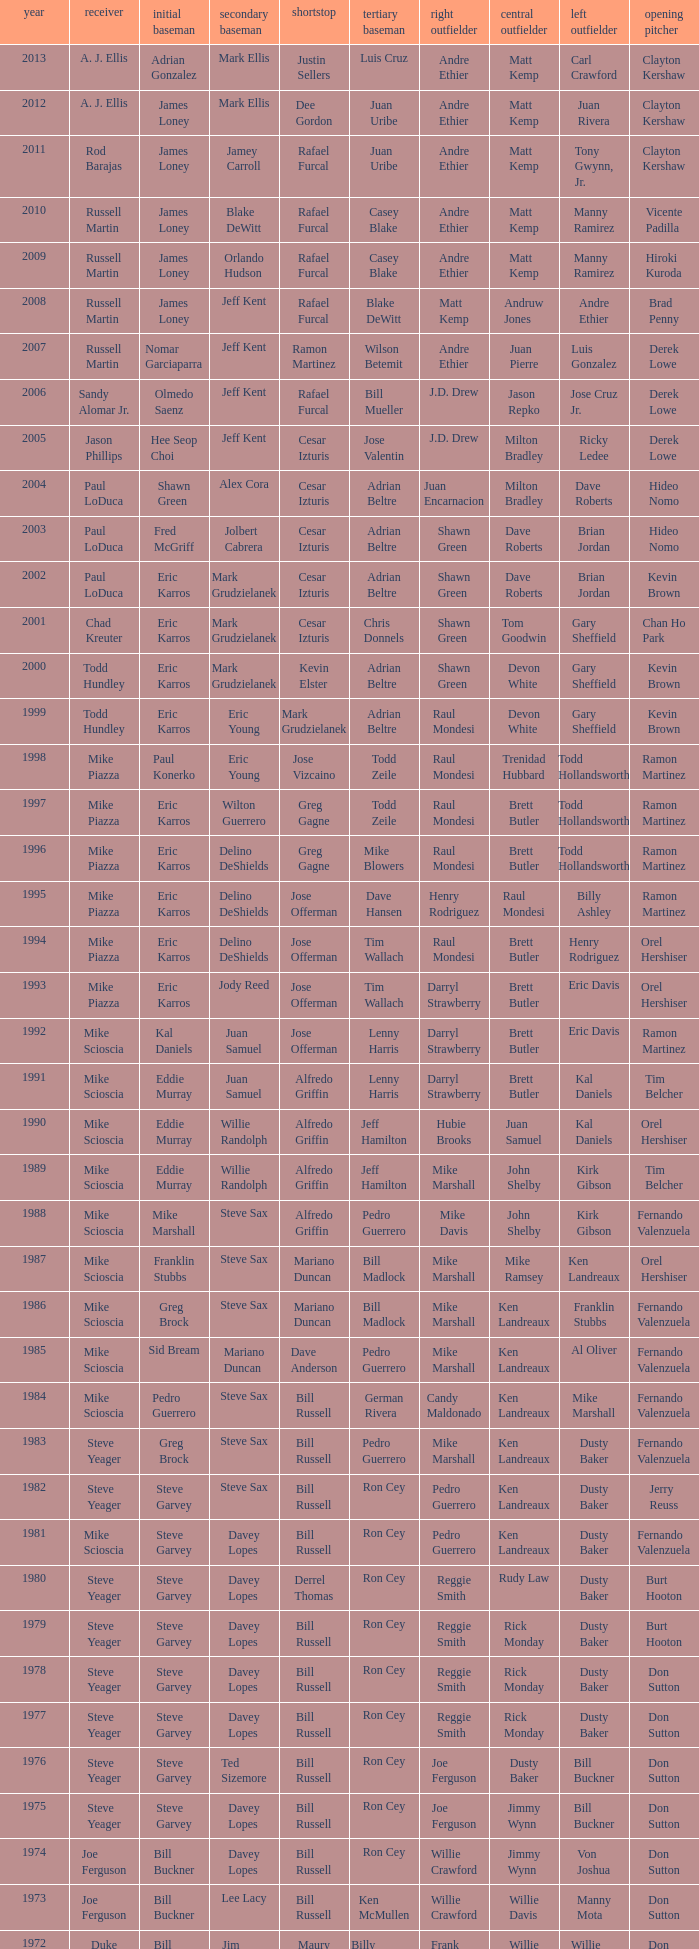Who was the RF when the SP was vicente padilla? Andre Ethier. 